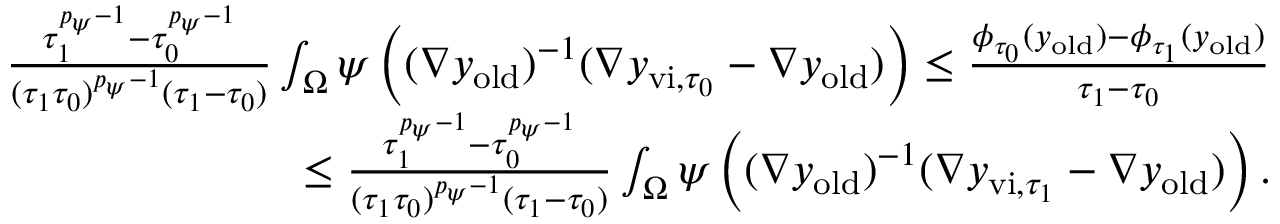<formula> <loc_0><loc_0><loc_500><loc_500>\begin{array} { r } { \frac { \tau _ { 1 } ^ { { p _ { \psi } - 1 } } - \tau _ { 0 } ^ { { p _ { \psi } - 1 } } } { ( \tau _ { 1 } \tau _ { 0 } ) ^ { p _ { \psi } - 1 } ( \tau _ { 1 } - \tau _ { 0 } ) } \int _ { \Omega } \psi \left ( ( \nabla y _ { o l d } ) ^ { - 1 } ( \nabla y _ { v i , { \tau _ { 0 } } } - \nabla y _ { o l d } ) \right ) \leq \frac { \phi _ { \tau _ { 0 } } ( y _ { o l d } ) - \phi _ { \tau _ { 1 } } ( y _ { o l d } ) } { \tau _ { 1 } - \tau _ { 0 } } } \\ { \quad \leq \frac { \tau _ { 1 } ^ { { p _ { \psi } - 1 } } - \tau _ { 0 } ^ { { p _ { \psi } - 1 } } } { ( \tau _ { 1 } \tau _ { 0 } ) ^ { p _ { \psi } - 1 } ( \tau _ { 1 } - \tau _ { 0 } ) } \int _ { \Omega } \psi \left ( ( \nabla y _ { o l d } ) ^ { - 1 } ( \nabla y _ { v i , { \tau _ { 1 } } } - \nabla y _ { o l d } ) \right ) . } \end{array}</formula> 